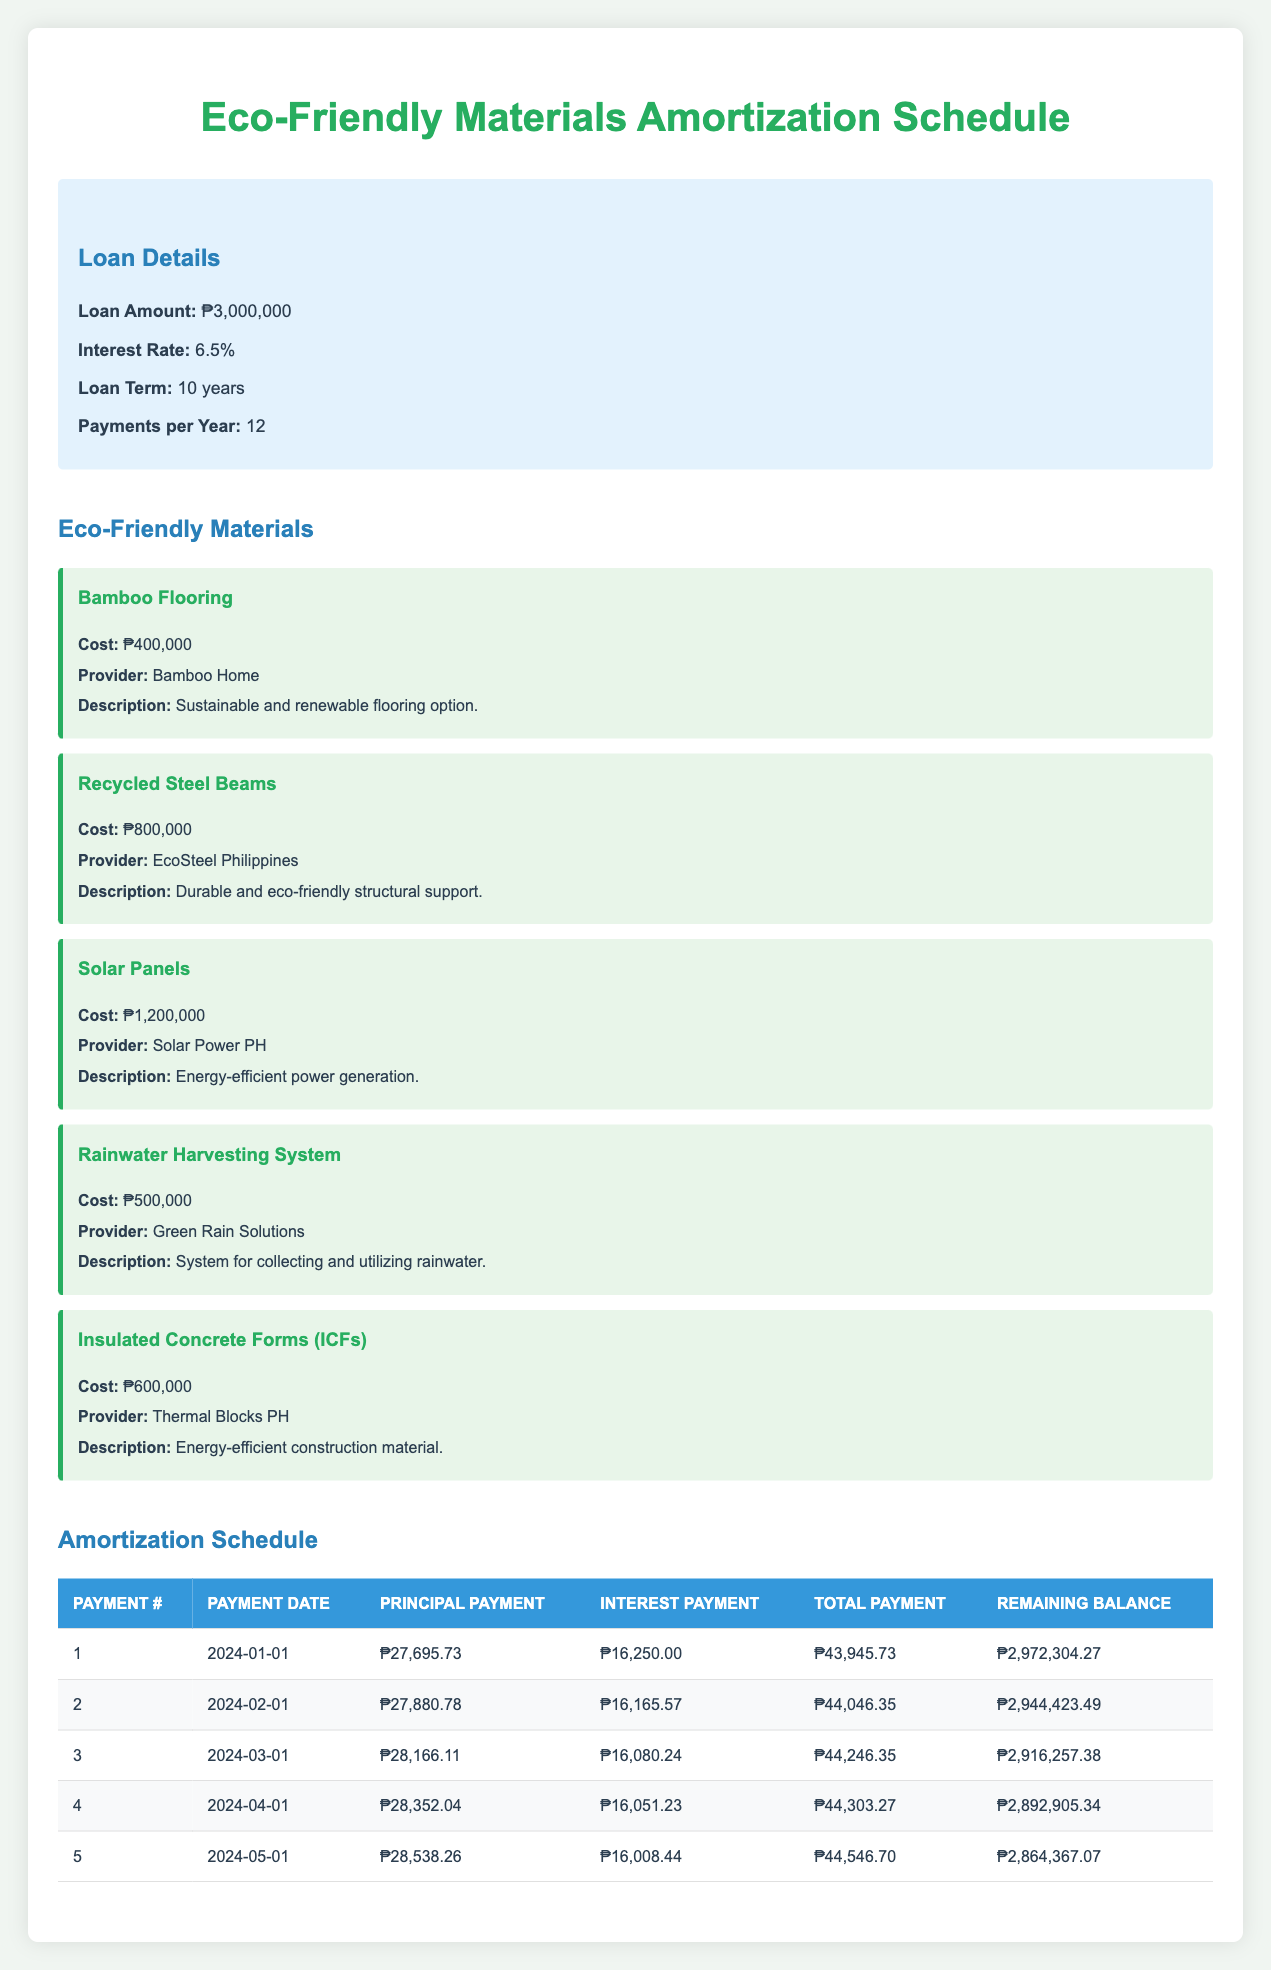What is the total payment for the first month? The total payment for the first month is listed under the "Total Payment" column for payment number 1, which is 43,945.73.
Answer: 43,945.73 What is the principal payment for the second month? The principal payment for the second month can be found in the "Principal Payment" column for payment number 2, which is 27,880.78.
Answer: 27,880.78 Is there an interest payment higher than 16,250.00 in the first five months? We check the "Interest Payment" column from payment numbers 1 through 5. The highest interest payment is 16,250.00 for payment number 1, and all subsequent payments are lower, so the answer is no.
Answer: No What is the remaining balance after the third payment? The remaining balance after the third payment is shown under the "Remaining Balance" column for payment number 3, which is 2,916,257.38.
Answer: 2,916,257.38 What is the average monthly principal payment for the first five payments? To find the average, we sum the principal payments for the first five payments: 27,695.73 + 27,880.78 + 28,166.11 + 28,352.04 + 28,538.26 = 140,632.92. Now, divide that by 5, giving us 140,632.92 / 5 = 28,126.58.
Answer: 28,126.58 What is the total interest payment for the first five months? We add up the interest payments for the first five payments: 16,250.00 + 16,165.57 + 16,080.24 + 16,051.23 + 16,008.44 = 80,555.48.
Answer: 80,555.48 Which payment has the highest total payment in the first five months? By examining the "Total Payment" column, we see that each total payment is: 43,945.73, 44,046.35, 44,246.35, 44,303.27, and 44,546.70. The highest value is 44,546.70 for payment number 5.
Answer: Payment number 5 What is the remaining balance after the fifth payment compared to the initial loan amount? The remaining balance after the fifth payment is 2,864,367.07, and the initial loan amount was 3,000,000. The difference is 3,000,000 - 2,864,367.07 = 135,632.93, so the remaining balance is lower than the initial loan amount.
Answer: 2,864,367.07 What is the total interest paid after the first four payments? We add the interest payments for the first four payments: 16,250.00 + 16,165.57 + 16,080.24 + 16,051.23 = 64,546.04.
Answer: 64,546.04 